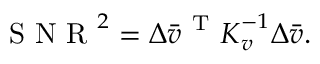<formula> <loc_0><loc_0><loc_500><loc_500>\begin{array} { r } { S N R ^ { 2 } = \Delta \bar { v } ^ { T } K _ { v } ^ { - 1 } \Delta \bar { v } . } \end{array}</formula> 